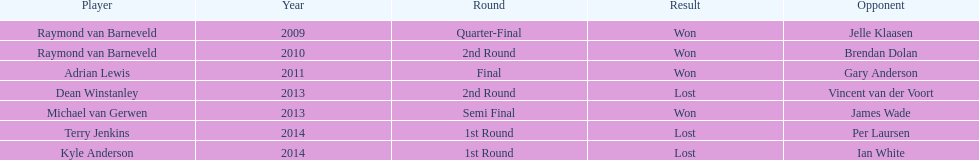Is dean winstanley listed above or below kyle anderson? Above. 